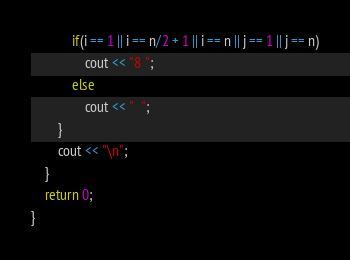Convert code to text. <code><loc_0><loc_0><loc_500><loc_500><_C++_>            if(i == 1 || i == n/2 + 1 || i == n || j == 1 || j == n)
                cout << "8 ";
            else
                cout << "  ";
        }
        cout << "\n";
    }
    return 0;
}</code> 